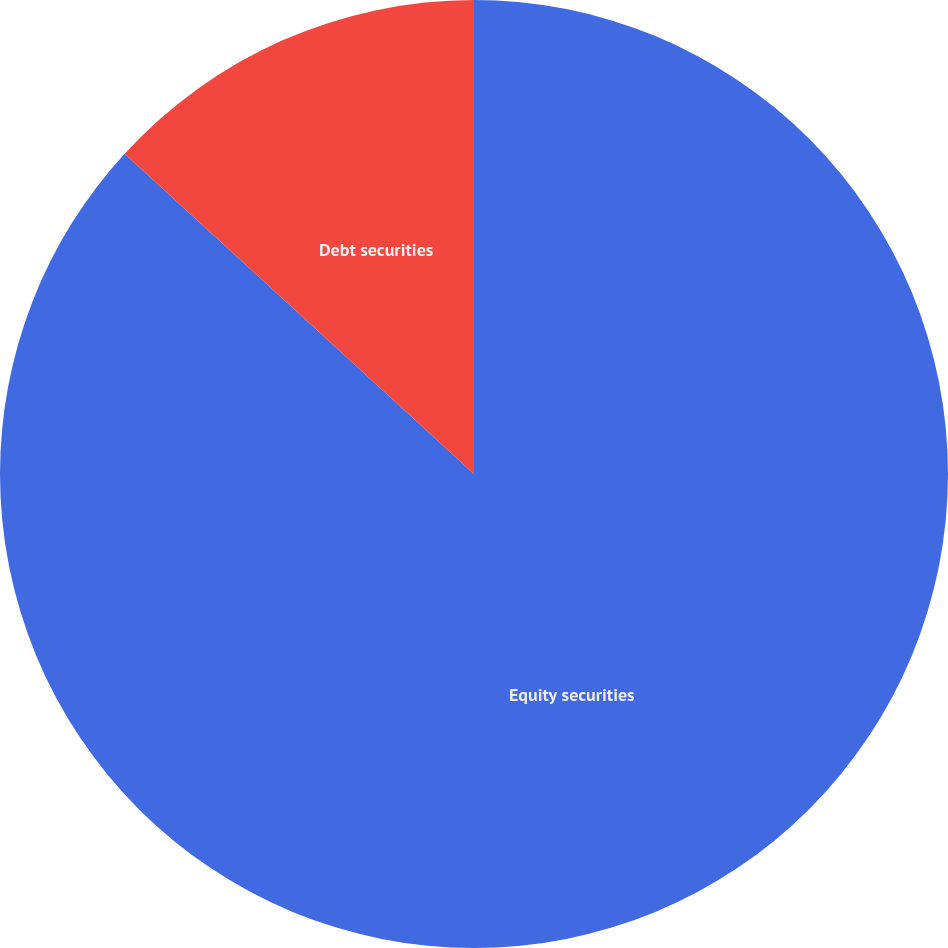Convert chart. <chart><loc_0><loc_0><loc_500><loc_500><pie_chart><fcel>Equity securities<fcel>Debt securities<nl><fcel>86.81%<fcel>13.19%<nl></chart> 